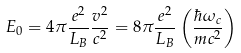Convert formula to latex. <formula><loc_0><loc_0><loc_500><loc_500>E _ { 0 } = { 4 \pi } { \frac { e ^ { 2 } } { L _ { B } } } { \frac { v ^ { 2 } } { c ^ { 2 } } } = { 8 \pi } { \frac { e ^ { 2 } } { L _ { B } } } \left ( { \frac { \hbar { \omega } _ { c } } { m c ^ { 2 } } } \right )</formula> 